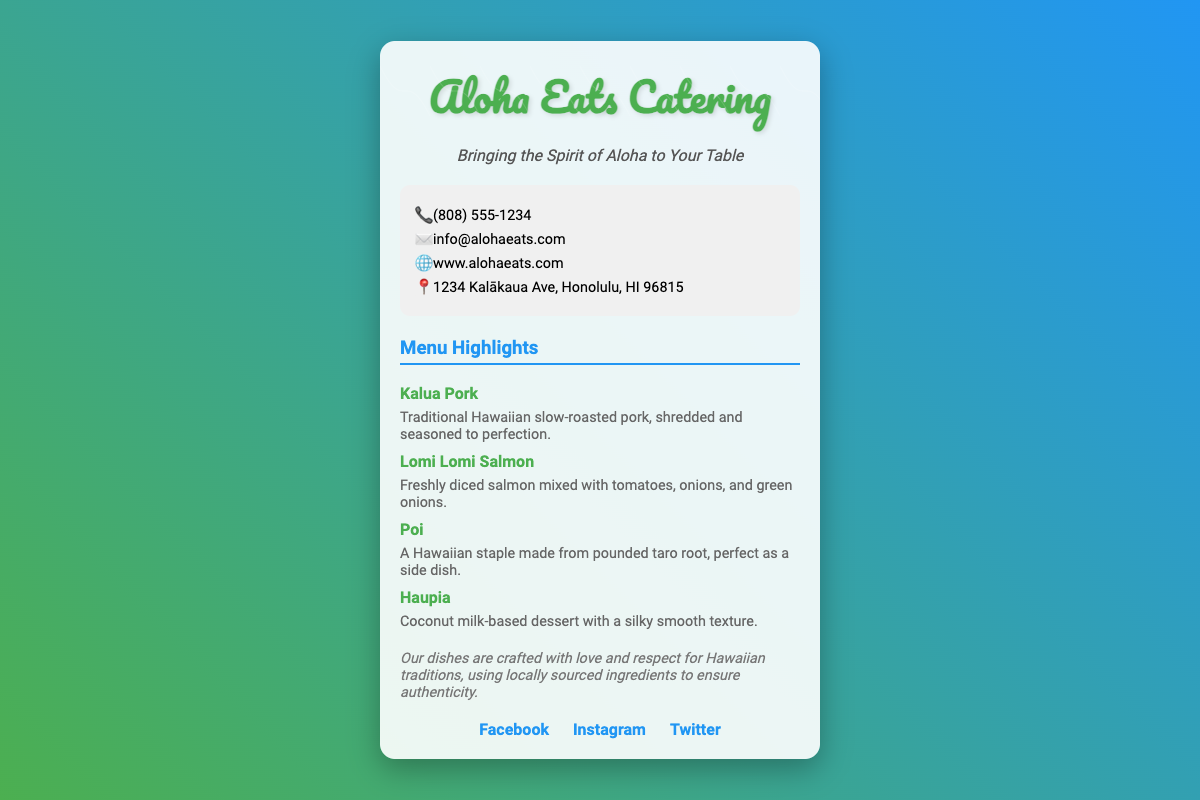What is the name of the catering service? The name of the catering service is directly stated at the top of the business card.
Answer: Aloha Eats Catering What is the phone number provided? The phone number is listed in the contact information section of the card.
Answer: (808) 555-1234 What type of cuisine does this service showcase? The cuisine type is indicated in both the description and menu highlights.
Answer: Native Hawaiian dishes What is one of the menu highlights mentioned? Menu highlights include specific dishes that are described on the card.
Answer: Kalua Pork Where is the catering service located? The location is given in the contact information section of the card.
Answer: 1234 Kalākaua Ave, Honolulu, HI 96815 What is the tagline of Aloha Eats Catering? The tagline is prominently displayed below the logo and conveys the service's mission.
Answer: Bringing the Spirit of Aloha to Your Table Which social media platforms are linked on the card? Social media links are provided for networking and marketing purposes.
Answer: Facebook, Instagram, Twitter What ingredient is used in Poi? The ingredient for Poi is specified in its description on the menu.
Answer: Taro root What type of dessert is Haupia? The document describes Haupia as a specific type of dessert without detailing its characteristics.
Answer: Coconut milk-based dessert 